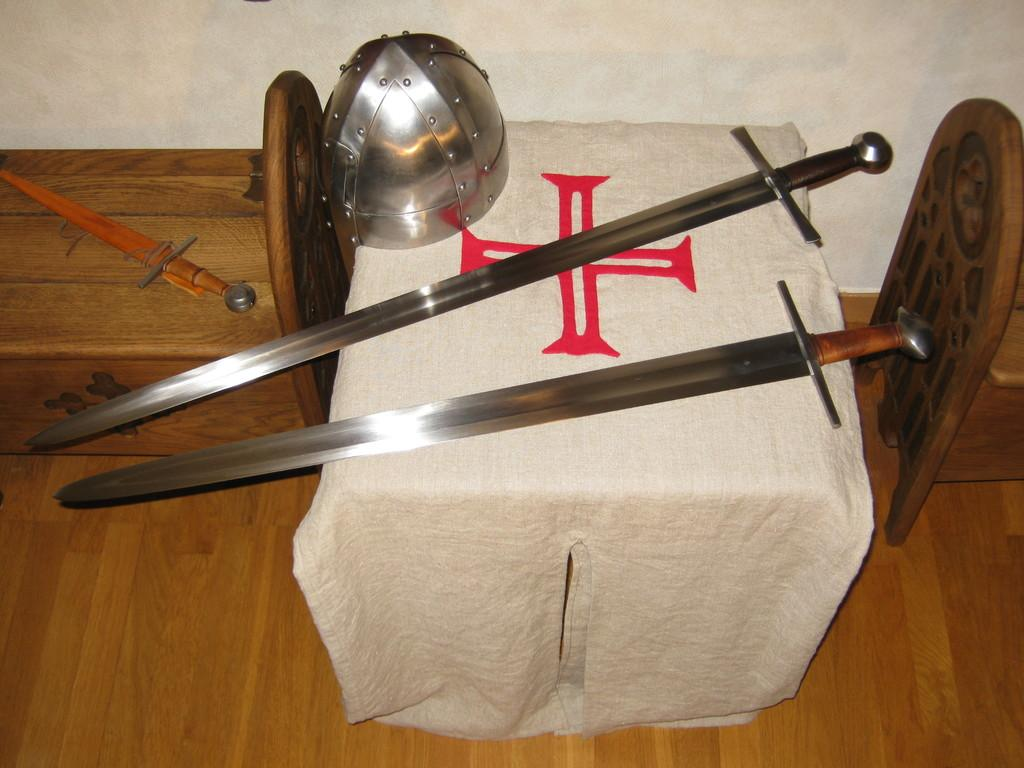What objects are on the tables in the image? There are swords and a helmet on the tables in the image. What can be seen in the background of the image? There is a wall visible in the background of the image. What type of hands are holding the swords in the image? There are no hands visible in the image; only the swords and helmet are present on the tables. What type of apparel is the horse wearing in the image? There is no horse present in the image, so it is not possible to determine what type of apparel it might be wearing. 